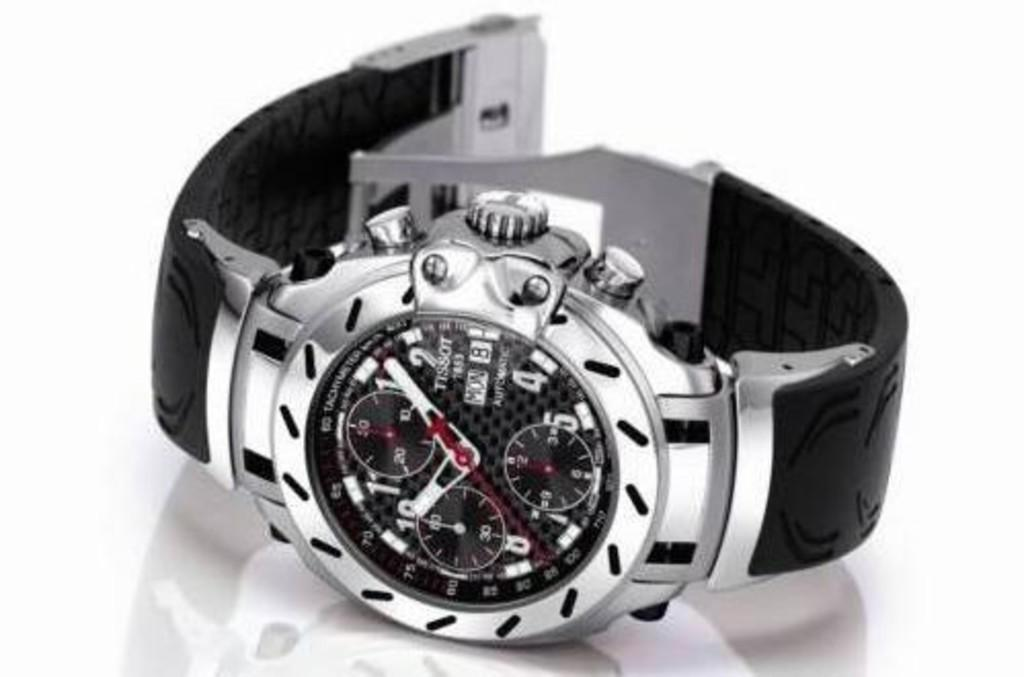<image>
Share a concise interpretation of the image provided. A Tissot watch says that today is Monday. 